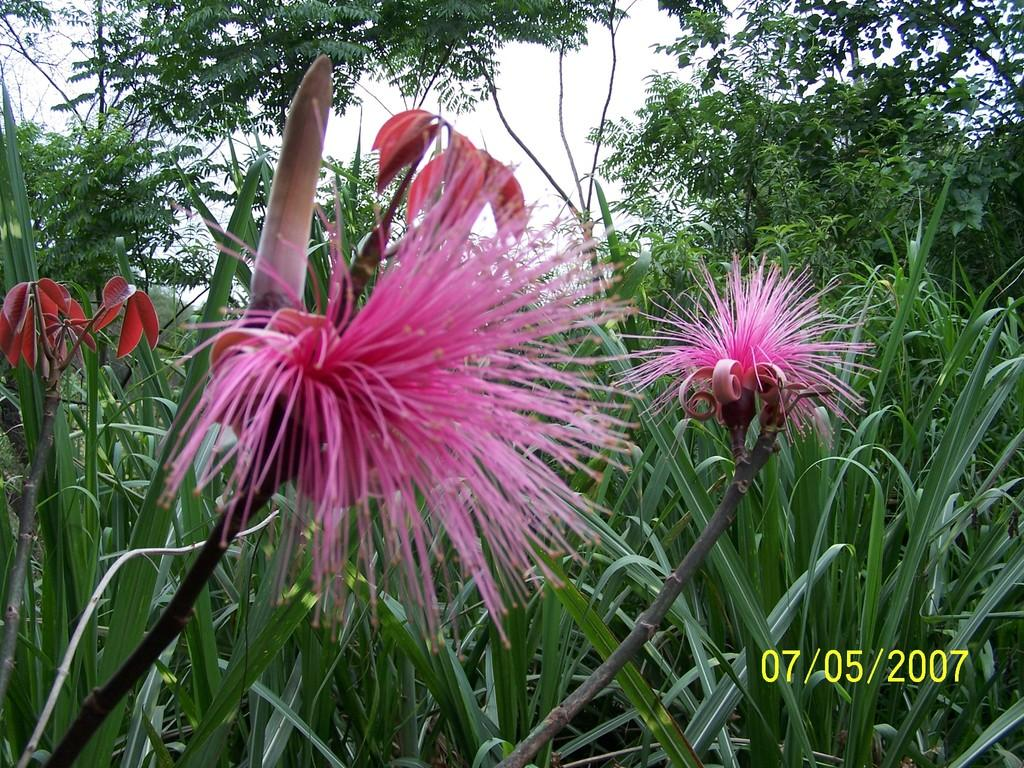What type of vegetation can be seen on the plants in the image? There are flowers on the plants in the image. What other types of vegetation are visible in the image? There are trees visible in the image. What invention is being demonstrated in the image? There is no invention being demonstrated in the image; it features flowers on plants and trees. What type of grain can be seen in the image? There is no grain present in the image. 